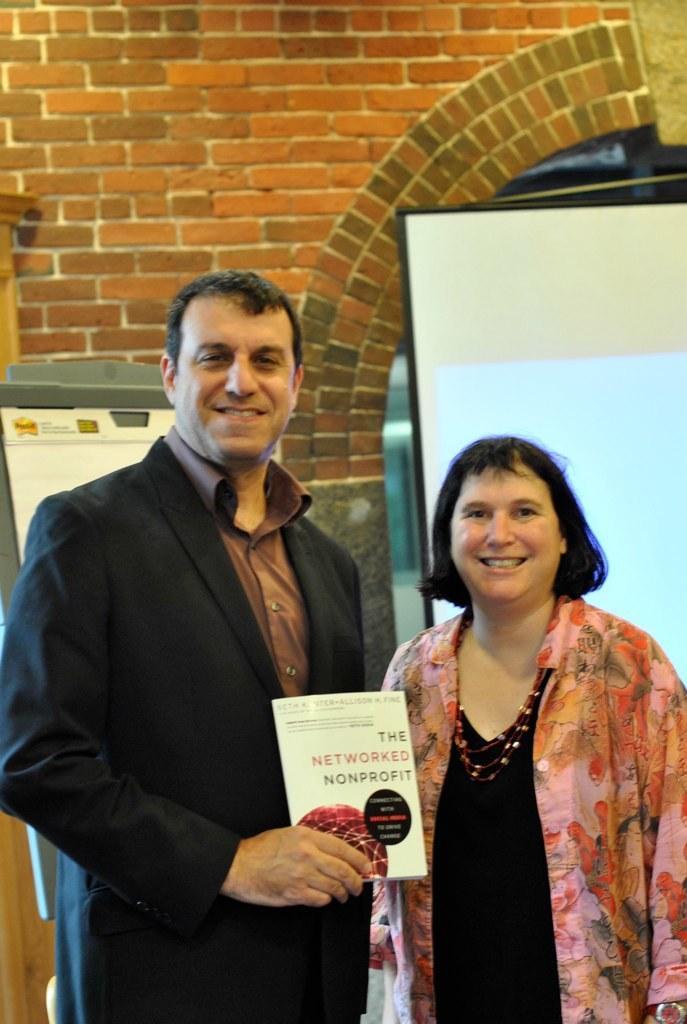How would you summarize this image in a sentence or two? In this image we can see two persons and among them a person is holding a book. On the book we can see the text and image. Behind the persons we can see a wall and a projector screen. On the left side, we can see a board with text. 